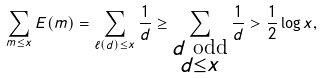Convert formula to latex. <formula><loc_0><loc_0><loc_500><loc_500>\sum _ { m \leq x } E ( m ) = \sum _ { \ell ( d ) \leq x } \frac { 1 } { d } \geq \sum _ { \substack { d \text { odd} \\ d \leq x } } \frac { 1 } { d } > \frac { 1 } { 2 } \log { x } ,</formula> 